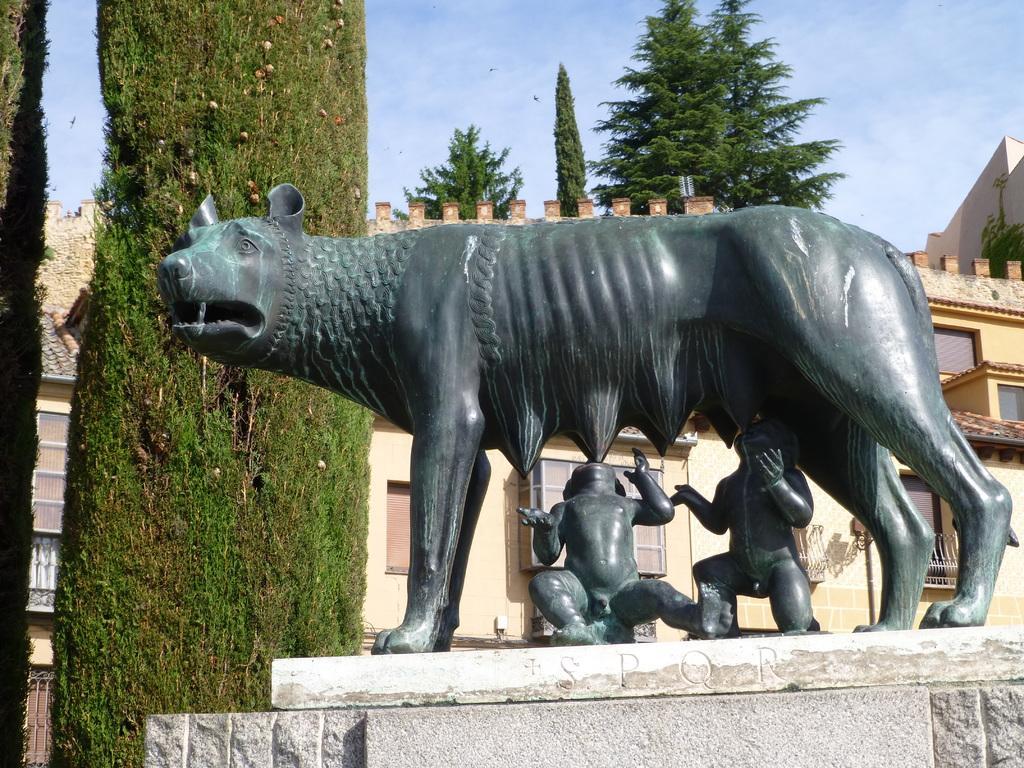How would you summarize this image in a sentence or two? Front we can see a statue. Background there is a building and trees. 